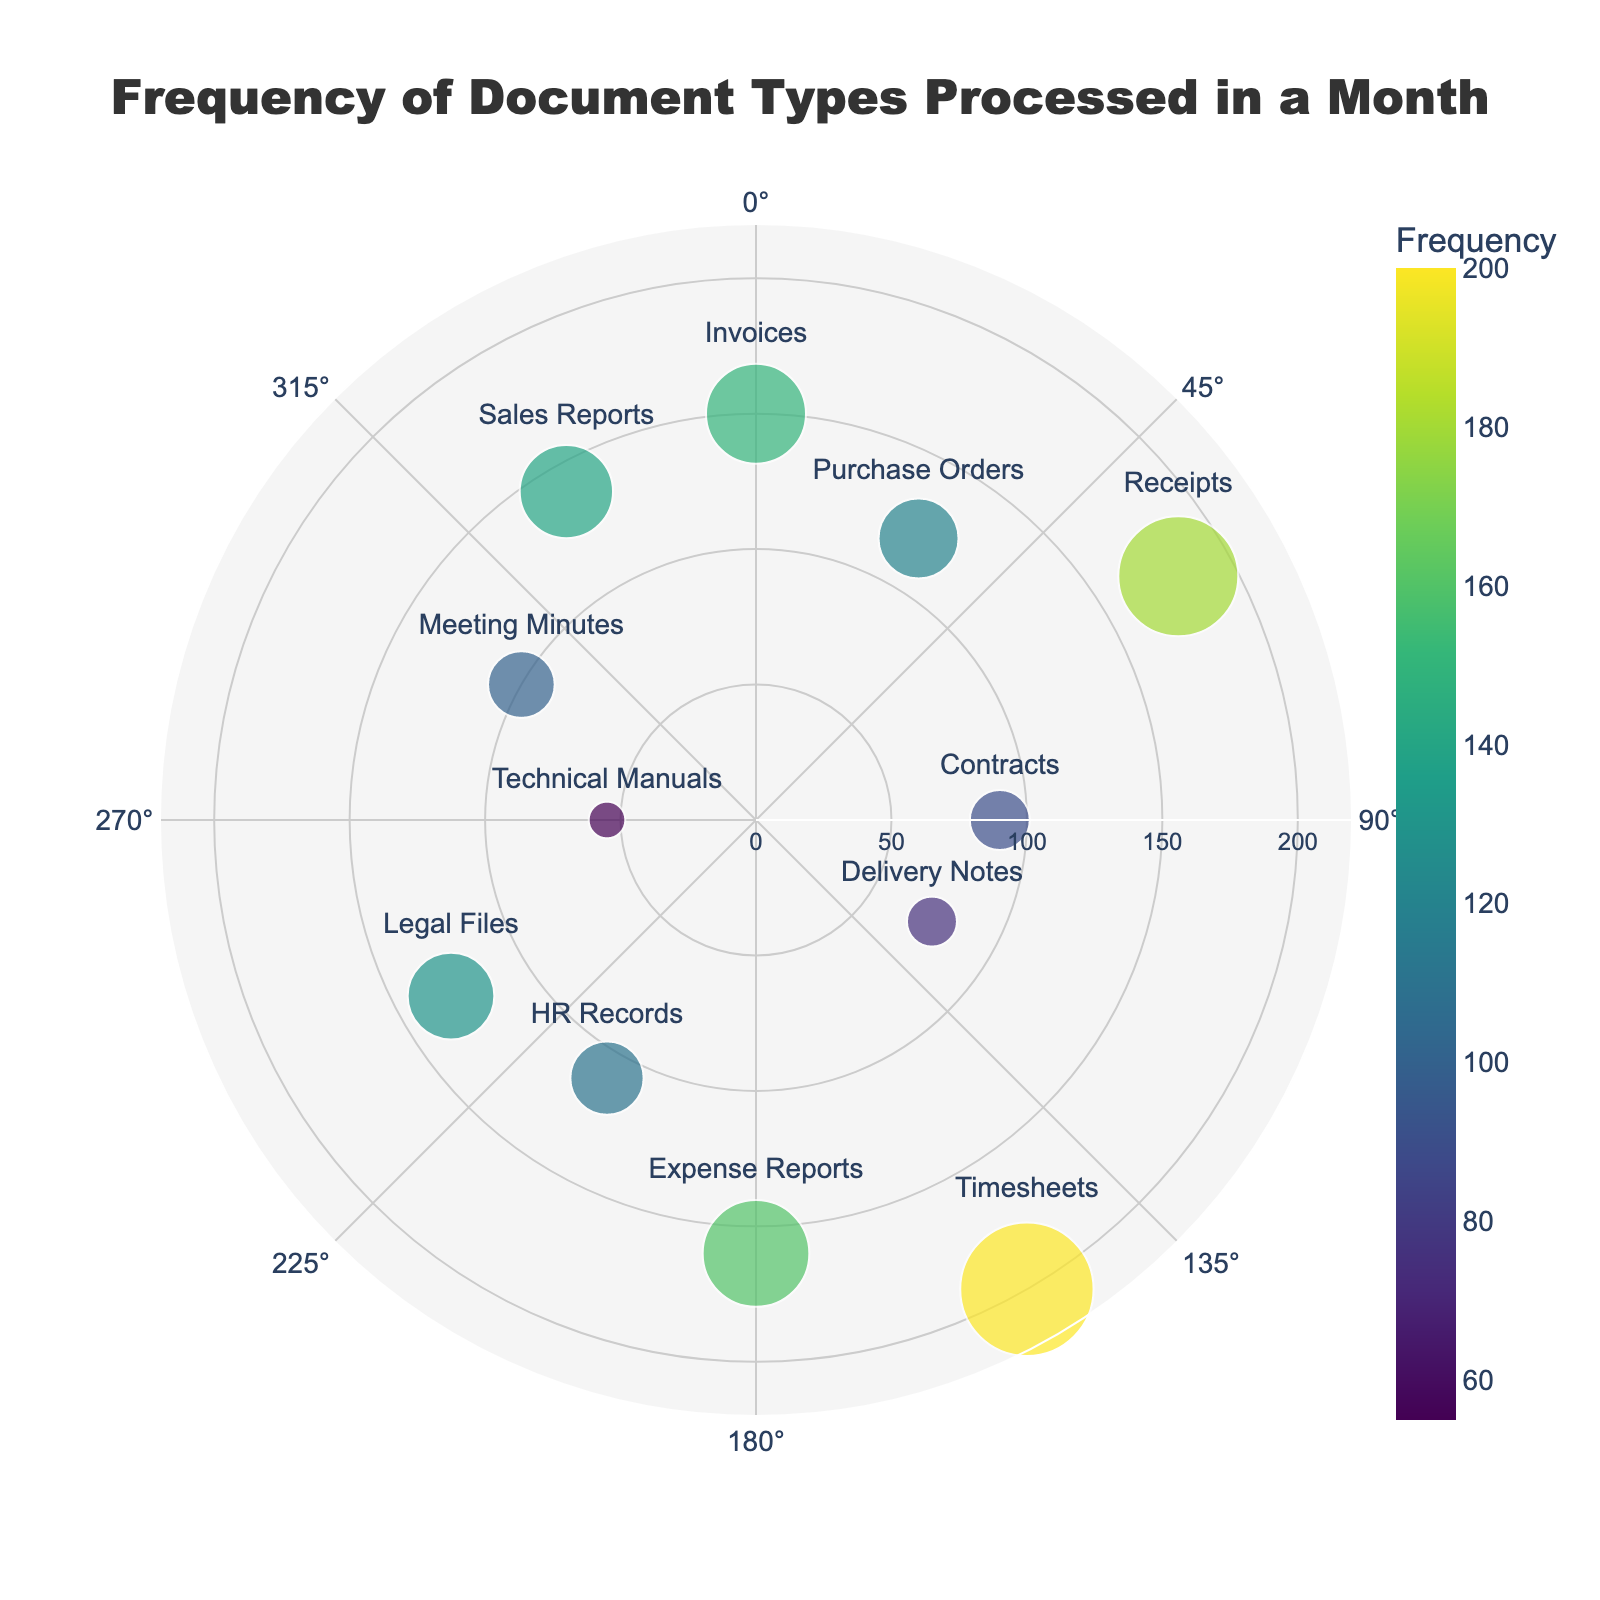what is the document type with the highest frequency? Looking at the plot, Timesheets have the largest marker size and are positioned at an angle of 150 degrees with the highest frequency of 200.
Answer: Timesheets Which document type is processed the least? The smallest marker size can be observed at an angle of 270 degrees, which corresponds to the Technical Manuals with a frequency of 55.
Answer: Technical Manuals What is the combined frequency of Invoices and Receipts? From the plot, Invoices have a frequency of 150 and Receipts have a frequency of 180. Summing these gives 150 + 180 = 330.
Answer: 330 Which document type has a higher frequency, Purchase Orders or Expense Reports? Purchase Orders are shown to have a frequency of 120, whereas Expense Reports have a frequency of 160. Thus, Expense Reports have a higher frequency.
Answer: Expense Reports What's the difference in frequency between Sales Reports and HR Records? Sales Reports have a frequency of 140 and HR Records have a frequency of 110. The difference is 140 - 110 = 30.
Answer: 30 How is the frequency distributed across quarterly intervals? Quarterly intervals can be approximated based on document types found near 0°, 90°, 180°, and 270°. Identifying these and adding their frequencies: Invoices (150) + Contracts (90) + Expense Reports (160) + Technical Manuals (55) = 455.
Answer: 455 Which document type is positioned at 210 degrees? Observing the angle on the plot, HR Records are placed at 210 degrees with a frequency of 110.
Answer: HR Records Is there any document type at the angle of 120 degrees? Yes, Delivery Notes are positioned at 120 degrees with a frequency of 75.
Answer: Delivery Notes What is the average frequency of the three document types with the smallest frequencies? The three document types with the smallest frequencies are Technical Manuals (55), Delivery Notes (75), and Contracts (90). Calculating the average: (55 + 75 + 90) / 3 = 73.33.
Answer: 73.33 